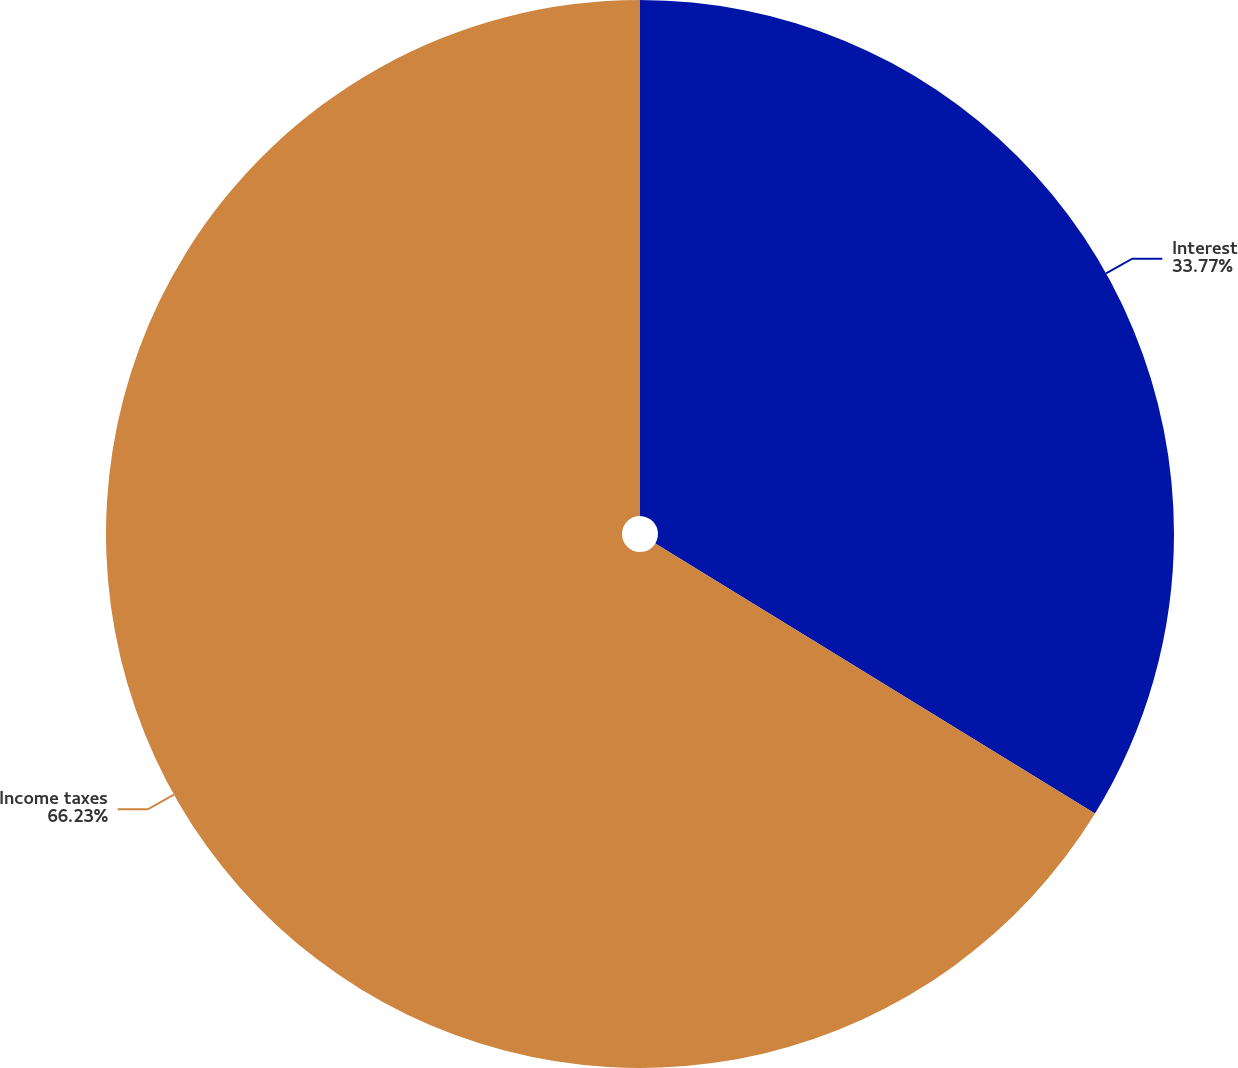Convert chart. <chart><loc_0><loc_0><loc_500><loc_500><pie_chart><fcel>Interest<fcel>Income taxes<nl><fcel>33.77%<fcel>66.23%<nl></chart> 